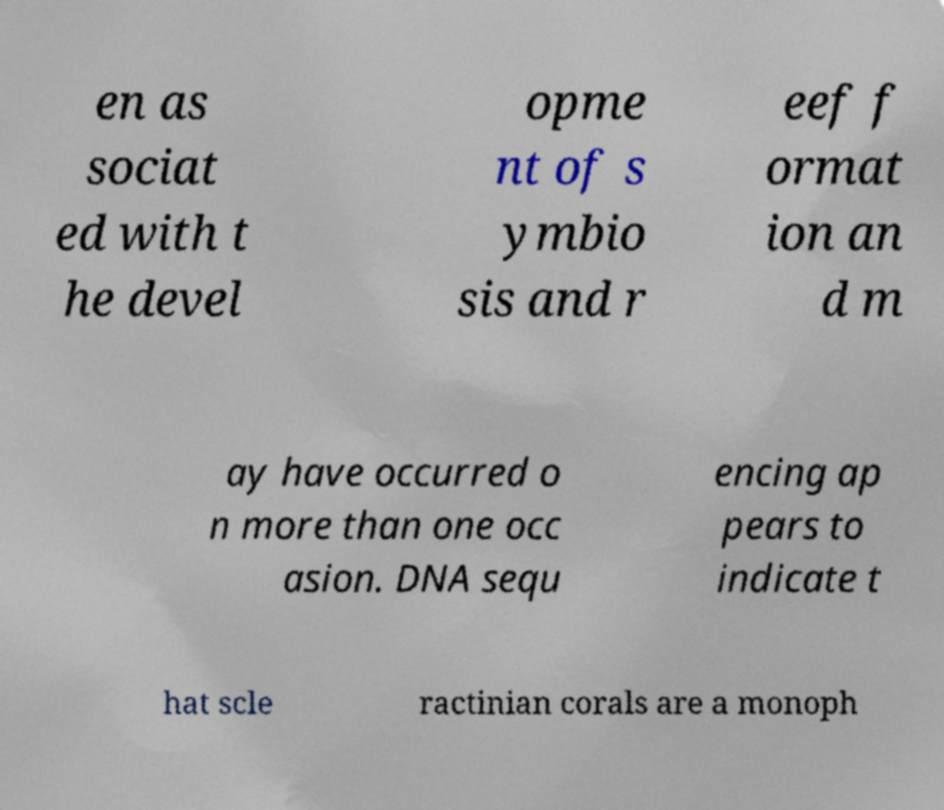Please identify and transcribe the text found in this image. en as sociat ed with t he devel opme nt of s ymbio sis and r eef f ormat ion an d m ay have occurred o n more than one occ asion. DNA sequ encing ap pears to indicate t hat scle ractinian corals are a monoph 